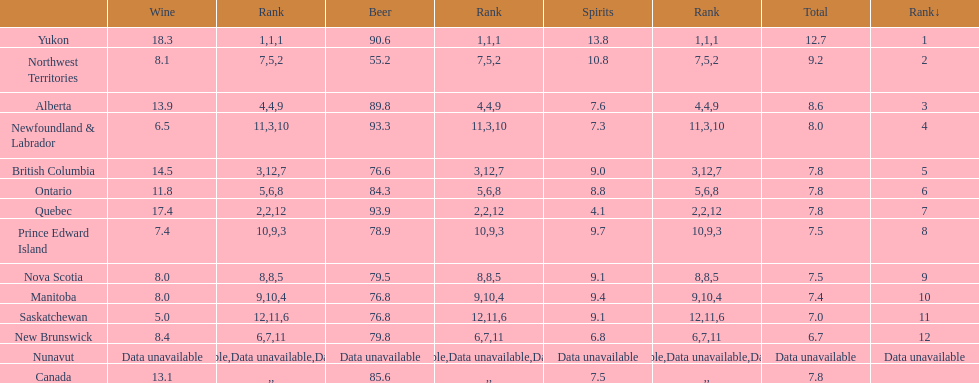Who consumed more beer - quebec or northwest territories? Quebec. 